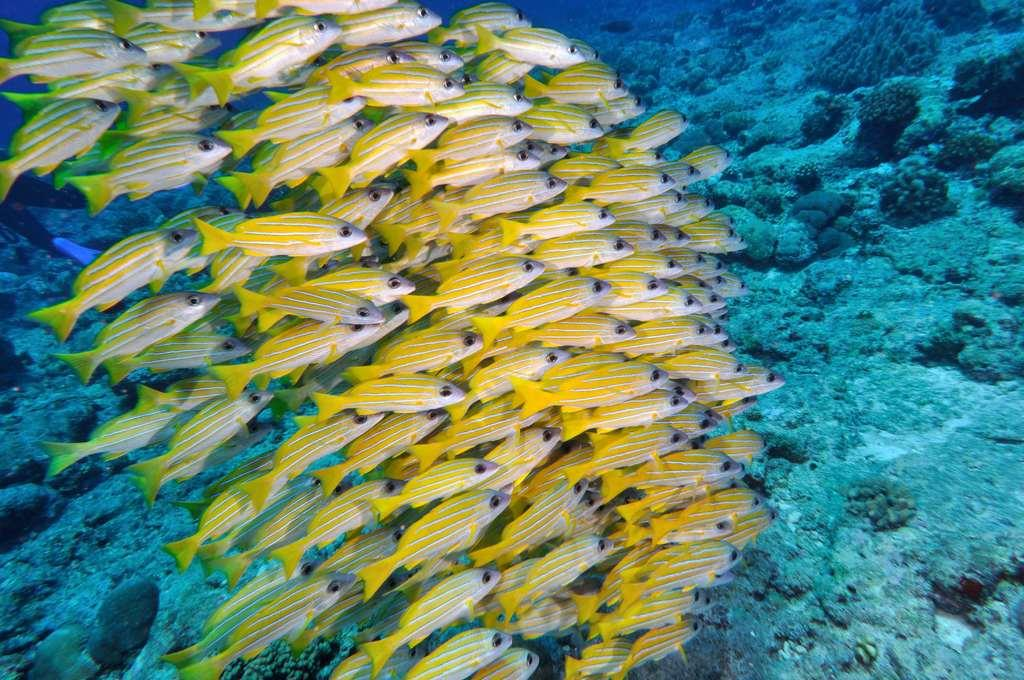What type of animals are in the image? There are fishes in the image. What color are the fishes? The fishes are in yellow color. What is the primary element in which the fishes are situated? There is water visible in the image, and the fishes are in it. What type of record can be seen being played by the fishes in the image? There is no record present in the image, and the fishes are not playing any records. What type of plane can be seen flying in the image? There is no plane present in the image. 